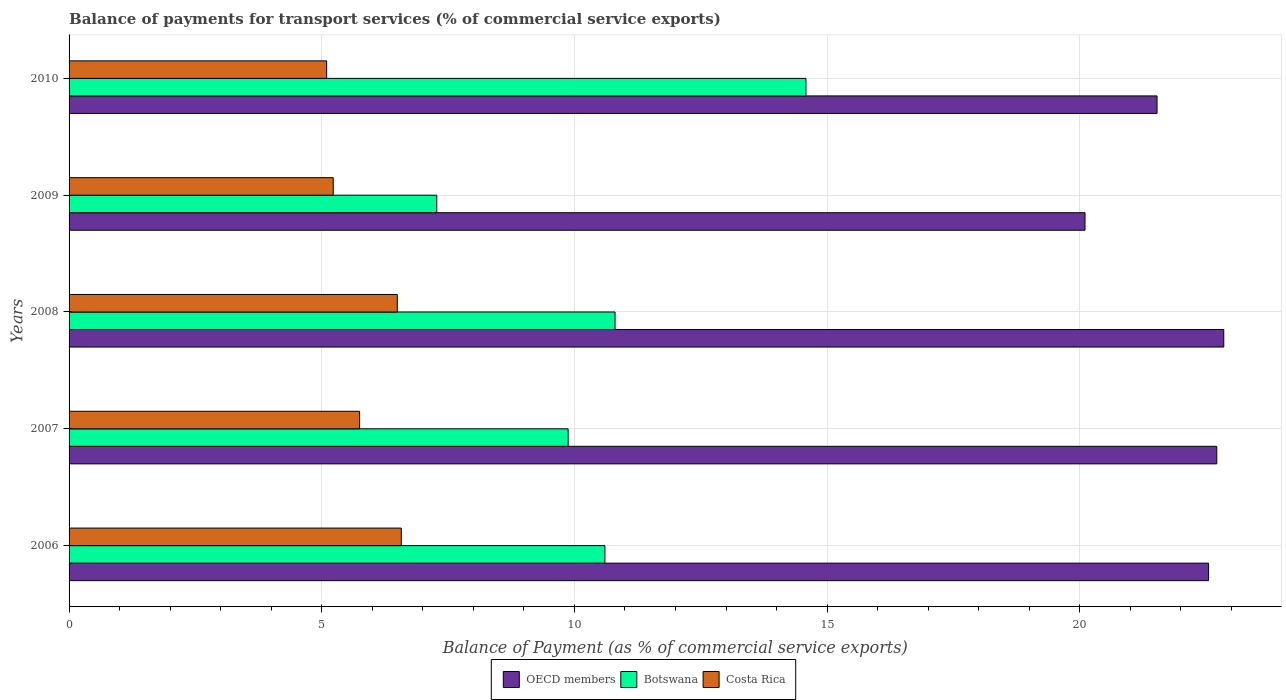How many groups of bars are there?
Your answer should be compact. 5. Are the number of bars per tick equal to the number of legend labels?
Provide a short and direct response. Yes. How many bars are there on the 2nd tick from the top?
Ensure brevity in your answer.  3. What is the balance of payments for transport services in Botswana in 2009?
Your answer should be very brief. 7.28. Across all years, what is the maximum balance of payments for transport services in Botswana?
Your answer should be very brief. 14.58. Across all years, what is the minimum balance of payments for transport services in Botswana?
Your answer should be very brief. 7.28. In which year was the balance of payments for transport services in Costa Rica minimum?
Give a very brief answer. 2010. What is the total balance of payments for transport services in Botswana in the graph?
Your response must be concise. 53.14. What is the difference between the balance of payments for transport services in OECD members in 2009 and that in 2010?
Give a very brief answer. -1.43. What is the difference between the balance of payments for transport services in OECD members in 2010 and the balance of payments for transport services in Botswana in 2009?
Keep it short and to the point. 14.25. What is the average balance of payments for transport services in Botswana per year?
Offer a very short reply. 10.63. In the year 2009, what is the difference between the balance of payments for transport services in Costa Rica and balance of payments for transport services in OECD members?
Keep it short and to the point. -14.88. What is the ratio of the balance of payments for transport services in OECD members in 2008 to that in 2010?
Ensure brevity in your answer.  1.06. Is the difference between the balance of payments for transport services in Costa Rica in 2007 and 2008 greater than the difference between the balance of payments for transport services in OECD members in 2007 and 2008?
Provide a short and direct response. No. What is the difference between the highest and the second highest balance of payments for transport services in Costa Rica?
Offer a terse response. 0.08. What is the difference between the highest and the lowest balance of payments for transport services in Costa Rica?
Make the answer very short. 1.48. What does the 2nd bar from the top in 2006 represents?
Your answer should be compact. Botswana. What does the 2nd bar from the bottom in 2008 represents?
Keep it short and to the point. Botswana. Is it the case that in every year, the sum of the balance of payments for transport services in Botswana and balance of payments for transport services in OECD members is greater than the balance of payments for transport services in Costa Rica?
Your answer should be compact. Yes. What is the difference between two consecutive major ticks on the X-axis?
Your response must be concise. 5. Are the values on the major ticks of X-axis written in scientific E-notation?
Your response must be concise. No. Does the graph contain any zero values?
Provide a short and direct response. No. Does the graph contain grids?
Make the answer very short. Yes. Where does the legend appear in the graph?
Ensure brevity in your answer.  Bottom center. How many legend labels are there?
Provide a succinct answer. 3. How are the legend labels stacked?
Provide a succinct answer. Horizontal. What is the title of the graph?
Offer a terse response. Balance of payments for transport services (% of commercial service exports). Does "Brazil" appear as one of the legend labels in the graph?
Your response must be concise. No. What is the label or title of the X-axis?
Keep it short and to the point. Balance of Payment (as % of commercial service exports). What is the Balance of Payment (as % of commercial service exports) in OECD members in 2006?
Your response must be concise. 22.55. What is the Balance of Payment (as % of commercial service exports) in Botswana in 2006?
Provide a short and direct response. 10.6. What is the Balance of Payment (as % of commercial service exports) in Costa Rica in 2006?
Provide a short and direct response. 6.57. What is the Balance of Payment (as % of commercial service exports) in OECD members in 2007?
Provide a short and direct response. 22.71. What is the Balance of Payment (as % of commercial service exports) in Botswana in 2007?
Your answer should be very brief. 9.88. What is the Balance of Payment (as % of commercial service exports) in Costa Rica in 2007?
Your answer should be compact. 5.75. What is the Balance of Payment (as % of commercial service exports) in OECD members in 2008?
Keep it short and to the point. 22.85. What is the Balance of Payment (as % of commercial service exports) in Botswana in 2008?
Make the answer very short. 10.8. What is the Balance of Payment (as % of commercial service exports) in Costa Rica in 2008?
Ensure brevity in your answer.  6.5. What is the Balance of Payment (as % of commercial service exports) of OECD members in 2009?
Make the answer very short. 20.1. What is the Balance of Payment (as % of commercial service exports) of Botswana in 2009?
Offer a terse response. 7.28. What is the Balance of Payment (as % of commercial service exports) of Costa Rica in 2009?
Provide a succinct answer. 5.23. What is the Balance of Payment (as % of commercial service exports) of OECD members in 2010?
Your answer should be very brief. 21.53. What is the Balance of Payment (as % of commercial service exports) of Botswana in 2010?
Your answer should be very brief. 14.58. What is the Balance of Payment (as % of commercial service exports) of Costa Rica in 2010?
Your response must be concise. 5.1. Across all years, what is the maximum Balance of Payment (as % of commercial service exports) in OECD members?
Offer a terse response. 22.85. Across all years, what is the maximum Balance of Payment (as % of commercial service exports) of Botswana?
Offer a terse response. 14.58. Across all years, what is the maximum Balance of Payment (as % of commercial service exports) in Costa Rica?
Provide a succinct answer. 6.57. Across all years, what is the minimum Balance of Payment (as % of commercial service exports) in OECD members?
Offer a terse response. 20.1. Across all years, what is the minimum Balance of Payment (as % of commercial service exports) in Botswana?
Provide a succinct answer. 7.28. Across all years, what is the minimum Balance of Payment (as % of commercial service exports) of Costa Rica?
Give a very brief answer. 5.1. What is the total Balance of Payment (as % of commercial service exports) in OECD members in the graph?
Provide a short and direct response. 109.75. What is the total Balance of Payment (as % of commercial service exports) in Botswana in the graph?
Give a very brief answer. 53.14. What is the total Balance of Payment (as % of commercial service exports) in Costa Rica in the graph?
Offer a terse response. 29.14. What is the difference between the Balance of Payment (as % of commercial service exports) of OECD members in 2006 and that in 2007?
Make the answer very short. -0.16. What is the difference between the Balance of Payment (as % of commercial service exports) of Botswana in 2006 and that in 2007?
Provide a short and direct response. 0.73. What is the difference between the Balance of Payment (as % of commercial service exports) of Costa Rica in 2006 and that in 2007?
Keep it short and to the point. 0.83. What is the difference between the Balance of Payment (as % of commercial service exports) of OECD members in 2006 and that in 2008?
Your response must be concise. -0.3. What is the difference between the Balance of Payment (as % of commercial service exports) of Botswana in 2006 and that in 2008?
Give a very brief answer. -0.2. What is the difference between the Balance of Payment (as % of commercial service exports) in Costa Rica in 2006 and that in 2008?
Provide a succinct answer. 0.08. What is the difference between the Balance of Payment (as % of commercial service exports) of OECD members in 2006 and that in 2009?
Your answer should be very brief. 2.45. What is the difference between the Balance of Payment (as % of commercial service exports) of Botswana in 2006 and that in 2009?
Ensure brevity in your answer.  3.33. What is the difference between the Balance of Payment (as % of commercial service exports) of Costa Rica in 2006 and that in 2009?
Keep it short and to the point. 1.35. What is the difference between the Balance of Payment (as % of commercial service exports) of OECD members in 2006 and that in 2010?
Make the answer very short. 1.02. What is the difference between the Balance of Payment (as % of commercial service exports) of Botswana in 2006 and that in 2010?
Give a very brief answer. -3.98. What is the difference between the Balance of Payment (as % of commercial service exports) of Costa Rica in 2006 and that in 2010?
Your answer should be very brief. 1.48. What is the difference between the Balance of Payment (as % of commercial service exports) of OECD members in 2007 and that in 2008?
Give a very brief answer. -0.14. What is the difference between the Balance of Payment (as % of commercial service exports) in Botswana in 2007 and that in 2008?
Offer a terse response. -0.93. What is the difference between the Balance of Payment (as % of commercial service exports) in Costa Rica in 2007 and that in 2008?
Ensure brevity in your answer.  -0.75. What is the difference between the Balance of Payment (as % of commercial service exports) in OECD members in 2007 and that in 2009?
Your response must be concise. 2.61. What is the difference between the Balance of Payment (as % of commercial service exports) of Botswana in 2007 and that in 2009?
Give a very brief answer. 2.6. What is the difference between the Balance of Payment (as % of commercial service exports) in Costa Rica in 2007 and that in 2009?
Provide a succinct answer. 0.52. What is the difference between the Balance of Payment (as % of commercial service exports) in OECD members in 2007 and that in 2010?
Your answer should be compact. 1.18. What is the difference between the Balance of Payment (as % of commercial service exports) of Botswana in 2007 and that in 2010?
Ensure brevity in your answer.  -4.71. What is the difference between the Balance of Payment (as % of commercial service exports) in Costa Rica in 2007 and that in 2010?
Offer a very short reply. 0.65. What is the difference between the Balance of Payment (as % of commercial service exports) of OECD members in 2008 and that in 2009?
Offer a very short reply. 2.75. What is the difference between the Balance of Payment (as % of commercial service exports) of Botswana in 2008 and that in 2009?
Make the answer very short. 3.53. What is the difference between the Balance of Payment (as % of commercial service exports) of Costa Rica in 2008 and that in 2009?
Offer a very short reply. 1.27. What is the difference between the Balance of Payment (as % of commercial service exports) in OECD members in 2008 and that in 2010?
Provide a succinct answer. 1.32. What is the difference between the Balance of Payment (as % of commercial service exports) of Botswana in 2008 and that in 2010?
Give a very brief answer. -3.78. What is the difference between the Balance of Payment (as % of commercial service exports) in Costa Rica in 2008 and that in 2010?
Offer a very short reply. 1.4. What is the difference between the Balance of Payment (as % of commercial service exports) of OECD members in 2009 and that in 2010?
Give a very brief answer. -1.43. What is the difference between the Balance of Payment (as % of commercial service exports) of Botswana in 2009 and that in 2010?
Your response must be concise. -7.31. What is the difference between the Balance of Payment (as % of commercial service exports) of Costa Rica in 2009 and that in 2010?
Provide a short and direct response. 0.13. What is the difference between the Balance of Payment (as % of commercial service exports) of OECD members in 2006 and the Balance of Payment (as % of commercial service exports) of Botswana in 2007?
Offer a very short reply. 12.67. What is the difference between the Balance of Payment (as % of commercial service exports) in OECD members in 2006 and the Balance of Payment (as % of commercial service exports) in Costa Rica in 2007?
Make the answer very short. 16.8. What is the difference between the Balance of Payment (as % of commercial service exports) of Botswana in 2006 and the Balance of Payment (as % of commercial service exports) of Costa Rica in 2007?
Give a very brief answer. 4.85. What is the difference between the Balance of Payment (as % of commercial service exports) in OECD members in 2006 and the Balance of Payment (as % of commercial service exports) in Botswana in 2008?
Make the answer very short. 11.75. What is the difference between the Balance of Payment (as % of commercial service exports) of OECD members in 2006 and the Balance of Payment (as % of commercial service exports) of Costa Rica in 2008?
Your answer should be very brief. 16.05. What is the difference between the Balance of Payment (as % of commercial service exports) of Botswana in 2006 and the Balance of Payment (as % of commercial service exports) of Costa Rica in 2008?
Give a very brief answer. 4.11. What is the difference between the Balance of Payment (as % of commercial service exports) of OECD members in 2006 and the Balance of Payment (as % of commercial service exports) of Botswana in 2009?
Offer a terse response. 15.27. What is the difference between the Balance of Payment (as % of commercial service exports) in OECD members in 2006 and the Balance of Payment (as % of commercial service exports) in Costa Rica in 2009?
Give a very brief answer. 17.32. What is the difference between the Balance of Payment (as % of commercial service exports) in Botswana in 2006 and the Balance of Payment (as % of commercial service exports) in Costa Rica in 2009?
Your answer should be very brief. 5.38. What is the difference between the Balance of Payment (as % of commercial service exports) in OECD members in 2006 and the Balance of Payment (as % of commercial service exports) in Botswana in 2010?
Offer a very short reply. 7.97. What is the difference between the Balance of Payment (as % of commercial service exports) of OECD members in 2006 and the Balance of Payment (as % of commercial service exports) of Costa Rica in 2010?
Keep it short and to the point. 17.45. What is the difference between the Balance of Payment (as % of commercial service exports) in Botswana in 2006 and the Balance of Payment (as % of commercial service exports) in Costa Rica in 2010?
Your answer should be very brief. 5.51. What is the difference between the Balance of Payment (as % of commercial service exports) in OECD members in 2007 and the Balance of Payment (as % of commercial service exports) in Botswana in 2008?
Your response must be concise. 11.91. What is the difference between the Balance of Payment (as % of commercial service exports) of OECD members in 2007 and the Balance of Payment (as % of commercial service exports) of Costa Rica in 2008?
Ensure brevity in your answer.  16.22. What is the difference between the Balance of Payment (as % of commercial service exports) in Botswana in 2007 and the Balance of Payment (as % of commercial service exports) in Costa Rica in 2008?
Ensure brevity in your answer.  3.38. What is the difference between the Balance of Payment (as % of commercial service exports) in OECD members in 2007 and the Balance of Payment (as % of commercial service exports) in Botswana in 2009?
Make the answer very short. 15.44. What is the difference between the Balance of Payment (as % of commercial service exports) in OECD members in 2007 and the Balance of Payment (as % of commercial service exports) in Costa Rica in 2009?
Offer a very short reply. 17.48. What is the difference between the Balance of Payment (as % of commercial service exports) in Botswana in 2007 and the Balance of Payment (as % of commercial service exports) in Costa Rica in 2009?
Offer a very short reply. 4.65. What is the difference between the Balance of Payment (as % of commercial service exports) of OECD members in 2007 and the Balance of Payment (as % of commercial service exports) of Botswana in 2010?
Offer a very short reply. 8.13. What is the difference between the Balance of Payment (as % of commercial service exports) of OECD members in 2007 and the Balance of Payment (as % of commercial service exports) of Costa Rica in 2010?
Offer a terse response. 17.61. What is the difference between the Balance of Payment (as % of commercial service exports) in Botswana in 2007 and the Balance of Payment (as % of commercial service exports) in Costa Rica in 2010?
Your answer should be compact. 4.78. What is the difference between the Balance of Payment (as % of commercial service exports) in OECD members in 2008 and the Balance of Payment (as % of commercial service exports) in Botswana in 2009?
Your response must be concise. 15.57. What is the difference between the Balance of Payment (as % of commercial service exports) in OECD members in 2008 and the Balance of Payment (as % of commercial service exports) in Costa Rica in 2009?
Keep it short and to the point. 17.62. What is the difference between the Balance of Payment (as % of commercial service exports) in Botswana in 2008 and the Balance of Payment (as % of commercial service exports) in Costa Rica in 2009?
Ensure brevity in your answer.  5.58. What is the difference between the Balance of Payment (as % of commercial service exports) in OECD members in 2008 and the Balance of Payment (as % of commercial service exports) in Botswana in 2010?
Offer a terse response. 8.27. What is the difference between the Balance of Payment (as % of commercial service exports) of OECD members in 2008 and the Balance of Payment (as % of commercial service exports) of Costa Rica in 2010?
Offer a very short reply. 17.75. What is the difference between the Balance of Payment (as % of commercial service exports) of Botswana in 2008 and the Balance of Payment (as % of commercial service exports) of Costa Rica in 2010?
Provide a succinct answer. 5.71. What is the difference between the Balance of Payment (as % of commercial service exports) in OECD members in 2009 and the Balance of Payment (as % of commercial service exports) in Botswana in 2010?
Keep it short and to the point. 5.52. What is the difference between the Balance of Payment (as % of commercial service exports) in OECD members in 2009 and the Balance of Payment (as % of commercial service exports) in Costa Rica in 2010?
Keep it short and to the point. 15.01. What is the difference between the Balance of Payment (as % of commercial service exports) in Botswana in 2009 and the Balance of Payment (as % of commercial service exports) in Costa Rica in 2010?
Provide a succinct answer. 2.18. What is the average Balance of Payment (as % of commercial service exports) in OECD members per year?
Provide a short and direct response. 21.95. What is the average Balance of Payment (as % of commercial service exports) in Botswana per year?
Your answer should be very brief. 10.63. What is the average Balance of Payment (as % of commercial service exports) of Costa Rica per year?
Your answer should be compact. 5.83. In the year 2006, what is the difference between the Balance of Payment (as % of commercial service exports) of OECD members and Balance of Payment (as % of commercial service exports) of Botswana?
Make the answer very short. 11.95. In the year 2006, what is the difference between the Balance of Payment (as % of commercial service exports) of OECD members and Balance of Payment (as % of commercial service exports) of Costa Rica?
Your answer should be very brief. 15.97. In the year 2006, what is the difference between the Balance of Payment (as % of commercial service exports) of Botswana and Balance of Payment (as % of commercial service exports) of Costa Rica?
Ensure brevity in your answer.  4.03. In the year 2007, what is the difference between the Balance of Payment (as % of commercial service exports) of OECD members and Balance of Payment (as % of commercial service exports) of Botswana?
Your answer should be very brief. 12.84. In the year 2007, what is the difference between the Balance of Payment (as % of commercial service exports) in OECD members and Balance of Payment (as % of commercial service exports) in Costa Rica?
Make the answer very short. 16.96. In the year 2007, what is the difference between the Balance of Payment (as % of commercial service exports) of Botswana and Balance of Payment (as % of commercial service exports) of Costa Rica?
Your response must be concise. 4.13. In the year 2008, what is the difference between the Balance of Payment (as % of commercial service exports) of OECD members and Balance of Payment (as % of commercial service exports) of Botswana?
Provide a short and direct response. 12.05. In the year 2008, what is the difference between the Balance of Payment (as % of commercial service exports) of OECD members and Balance of Payment (as % of commercial service exports) of Costa Rica?
Ensure brevity in your answer.  16.35. In the year 2008, what is the difference between the Balance of Payment (as % of commercial service exports) in Botswana and Balance of Payment (as % of commercial service exports) in Costa Rica?
Provide a succinct answer. 4.31. In the year 2009, what is the difference between the Balance of Payment (as % of commercial service exports) in OECD members and Balance of Payment (as % of commercial service exports) in Botswana?
Give a very brief answer. 12.83. In the year 2009, what is the difference between the Balance of Payment (as % of commercial service exports) in OECD members and Balance of Payment (as % of commercial service exports) in Costa Rica?
Give a very brief answer. 14.88. In the year 2009, what is the difference between the Balance of Payment (as % of commercial service exports) of Botswana and Balance of Payment (as % of commercial service exports) of Costa Rica?
Your response must be concise. 2.05. In the year 2010, what is the difference between the Balance of Payment (as % of commercial service exports) of OECD members and Balance of Payment (as % of commercial service exports) of Botswana?
Keep it short and to the point. 6.95. In the year 2010, what is the difference between the Balance of Payment (as % of commercial service exports) in OECD members and Balance of Payment (as % of commercial service exports) in Costa Rica?
Make the answer very short. 16.43. In the year 2010, what is the difference between the Balance of Payment (as % of commercial service exports) in Botswana and Balance of Payment (as % of commercial service exports) in Costa Rica?
Give a very brief answer. 9.48. What is the ratio of the Balance of Payment (as % of commercial service exports) of OECD members in 2006 to that in 2007?
Your response must be concise. 0.99. What is the ratio of the Balance of Payment (as % of commercial service exports) of Botswana in 2006 to that in 2007?
Keep it short and to the point. 1.07. What is the ratio of the Balance of Payment (as % of commercial service exports) in Costa Rica in 2006 to that in 2007?
Offer a very short reply. 1.14. What is the ratio of the Balance of Payment (as % of commercial service exports) of OECD members in 2006 to that in 2008?
Provide a short and direct response. 0.99. What is the ratio of the Balance of Payment (as % of commercial service exports) of Botswana in 2006 to that in 2008?
Your response must be concise. 0.98. What is the ratio of the Balance of Payment (as % of commercial service exports) of Costa Rica in 2006 to that in 2008?
Offer a terse response. 1.01. What is the ratio of the Balance of Payment (as % of commercial service exports) in OECD members in 2006 to that in 2009?
Provide a succinct answer. 1.12. What is the ratio of the Balance of Payment (as % of commercial service exports) in Botswana in 2006 to that in 2009?
Make the answer very short. 1.46. What is the ratio of the Balance of Payment (as % of commercial service exports) in Costa Rica in 2006 to that in 2009?
Make the answer very short. 1.26. What is the ratio of the Balance of Payment (as % of commercial service exports) of OECD members in 2006 to that in 2010?
Your answer should be very brief. 1.05. What is the ratio of the Balance of Payment (as % of commercial service exports) of Botswana in 2006 to that in 2010?
Offer a very short reply. 0.73. What is the ratio of the Balance of Payment (as % of commercial service exports) in Costa Rica in 2006 to that in 2010?
Give a very brief answer. 1.29. What is the ratio of the Balance of Payment (as % of commercial service exports) of OECD members in 2007 to that in 2008?
Your answer should be compact. 0.99. What is the ratio of the Balance of Payment (as % of commercial service exports) in Botswana in 2007 to that in 2008?
Provide a short and direct response. 0.91. What is the ratio of the Balance of Payment (as % of commercial service exports) in Costa Rica in 2007 to that in 2008?
Provide a short and direct response. 0.89. What is the ratio of the Balance of Payment (as % of commercial service exports) in OECD members in 2007 to that in 2009?
Offer a very short reply. 1.13. What is the ratio of the Balance of Payment (as % of commercial service exports) in Botswana in 2007 to that in 2009?
Provide a succinct answer. 1.36. What is the ratio of the Balance of Payment (as % of commercial service exports) of Costa Rica in 2007 to that in 2009?
Your response must be concise. 1.1. What is the ratio of the Balance of Payment (as % of commercial service exports) in OECD members in 2007 to that in 2010?
Offer a very short reply. 1.05. What is the ratio of the Balance of Payment (as % of commercial service exports) of Botswana in 2007 to that in 2010?
Ensure brevity in your answer.  0.68. What is the ratio of the Balance of Payment (as % of commercial service exports) in Costa Rica in 2007 to that in 2010?
Give a very brief answer. 1.13. What is the ratio of the Balance of Payment (as % of commercial service exports) in OECD members in 2008 to that in 2009?
Provide a short and direct response. 1.14. What is the ratio of the Balance of Payment (as % of commercial service exports) of Botswana in 2008 to that in 2009?
Provide a short and direct response. 1.48. What is the ratio of the Balance of Payment (as % of commercial service exports) in Costa Rica in 2008 to that in 2009?
Give a very brief answer. 1.24. What is the ratio of the Balance of Payment (as % of commercial service exports) in OECD members in 2008 to that in 2010?
Provide a succinct answer. 1.06. What is the ratio of the Balance of Payment (as % of commercial service exports) in Botswana in 2008 to that in 2010?
Give a very brief answer. 0.74. What is the ratio of the Balance of Payment (as % of commercial service exports) in Costa Rica in 2008 to that in 2010?
Offer a very short reply. 1.27. What is the ratio of the Balance of Payment (as % of commercial service exports) in OECD members in 2009 to that in 2010?
Offer a terse response. 0.93. What is the ratio of the Balance of Payment (as % of commercial service exports) of Botswana in 2009 to that in 2010?
Your answer should be compact. 0.5. What is the ratio of the Balance of Payment (as % of commercial service exports) of Costa Rica in 2009 to that in 2010?
Offer a terse response. 1.03. What is the difference between the highest and the second highest Balance of Payment (as % of commercial service exports) in OECD members?
Give a very brief answer. 0.14. What is the difference between the highest and the second highest Balance of Payment (as % of commercial service exports) of Botswana?
Your answer should be compact. 3.78. What is the difference between the highest and the second highest Balance of Payment (as % of commercial service exports) in Costa Rica?
Make the answer very short. 0.08. What is the difference between the highest and the lowest Balance of Payment (as % of commercial service exports) of OECD members?
Give a very brief answer. 2.75. What is the difference between the highest and the lowest Balance of Payment (as % of commercial service exports) in Botswana?
Offer a terse response. 7.31. What is the difference between the highest and the lowest Balance of Payment (as % of commercial service exports) of Costa Rica?
Your answer should be compact. 1.48. 